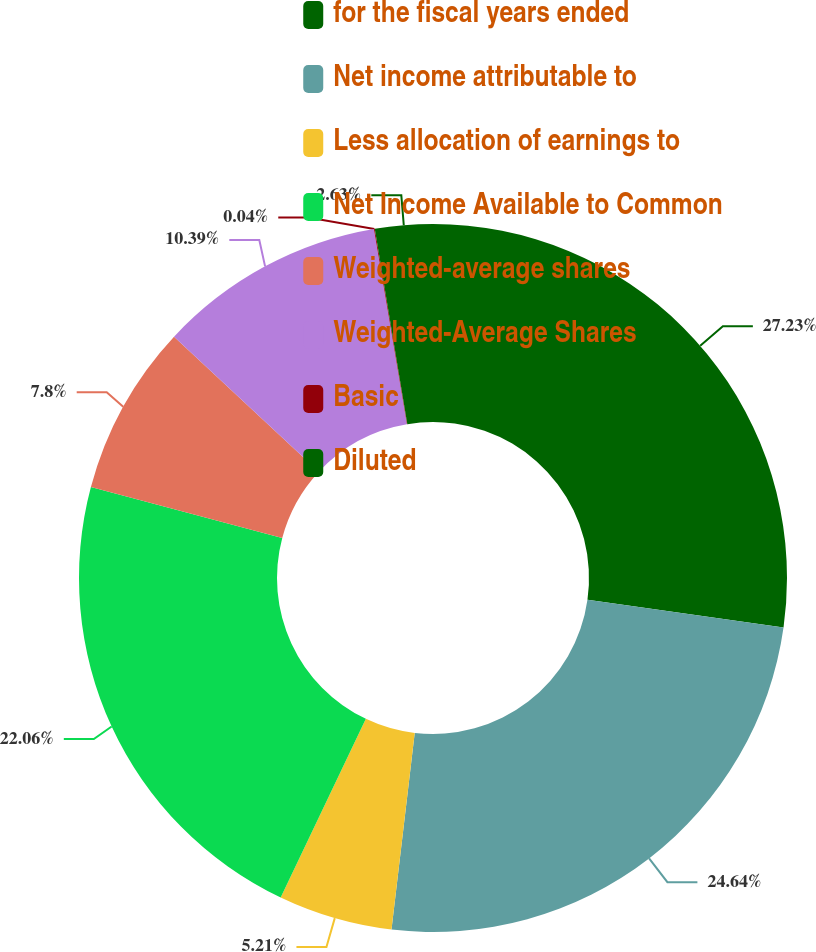Convert chart to OTSL. <chart><loc_0><loc_0><loc_500><loc_500><pie_chart><fcel>for the fiscal years ended<fcel>Net income attributable to<fcel>Less allocation of earnings to<fcel>Net Income Available to Common<fcel>Weighted-average shares<fcel>Weighted-Average Shares<fcel>Basic<fcel>Diluted<nl><fcel>27.23%<fcel>24.64%<fcel>5.21%<fcel>22.06%<fcel>7.8%<fcel>10.39%<fcel>0.04%<fcel>2.63%<nl></chart> 